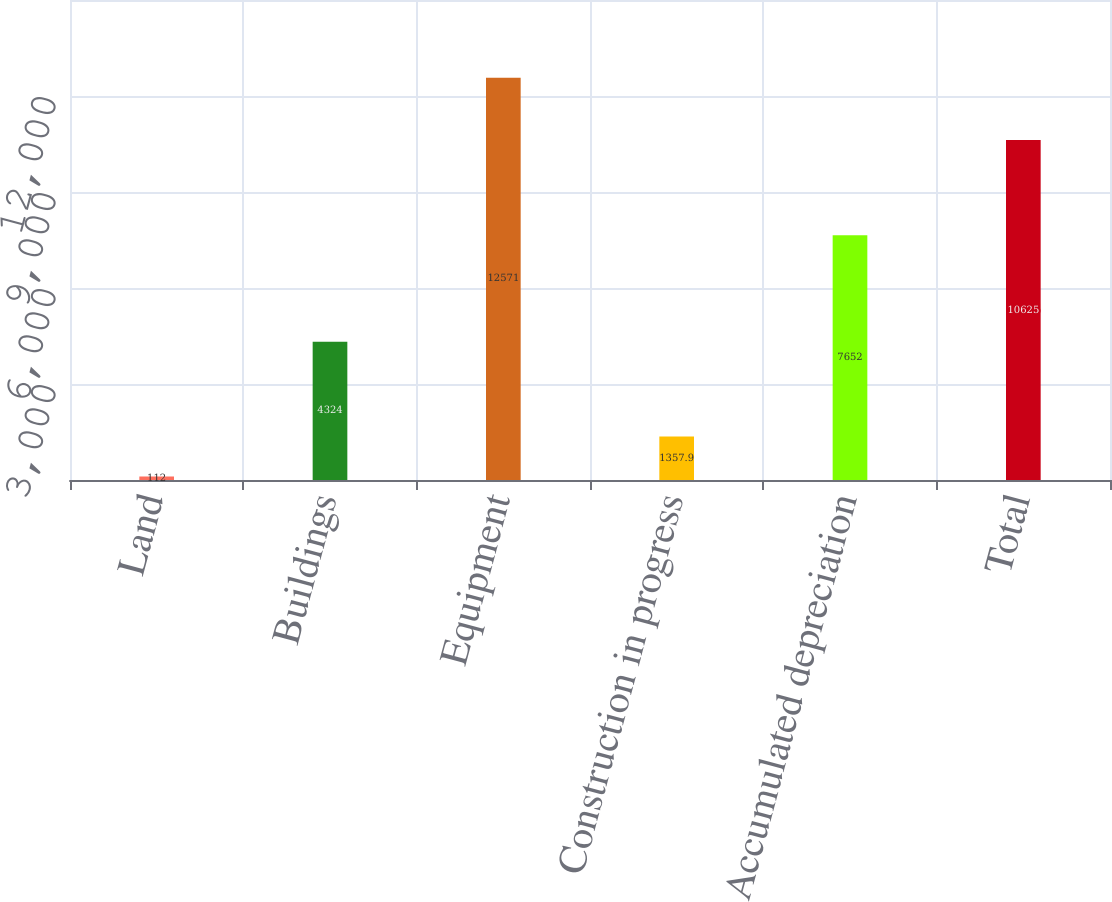Convert chart to OTSL. <chart><loc_0><loc_0><loc_500><loc_500><bar_chart><fcel>Land<fcel>Buildings<fcel>Equipment<fcel>Construction in progress<fcel>Accumulated depreciation<fcel>Total<nl><fcel>112<fcel>4324<fcel>12571<fcel>1357.9<fcel>7652<fcel>10625<nl></chart> 